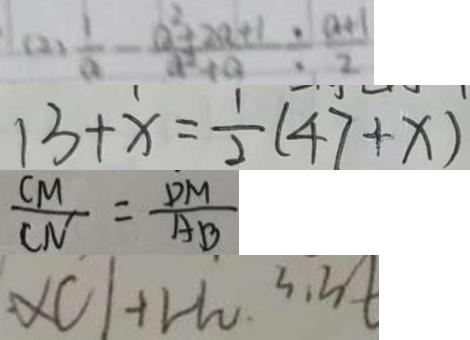Convert formula to latex. <formula><loc_0><loc_0><loc_500><loc_500>( 2 ) \frac { 1 } { a } - \frac { a ^ { 2 } + 2 a + 1 } { a ^ { 2 } + a } \div \frac { a + 1 } { 2 } 
 1 3 + x = \frac { 1 } { 2 } ( 4 7 + x ) 
 \frac { C M } { C N } = \frac { D M } { A B } 
 \times C l + H _ { 2 } 3 . 3 t</formula> 